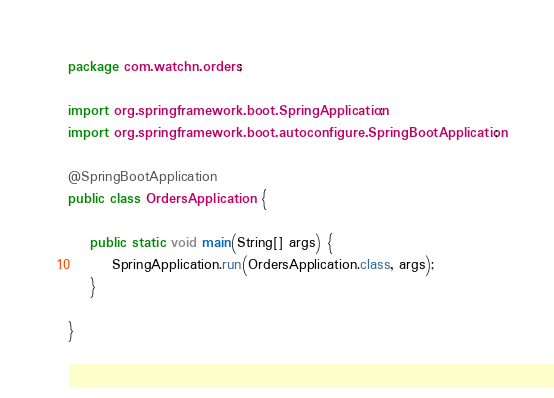<code> <loc_0><loc_0><loc_500><loc_500><_Java_>package com.watchn.orders;

import org.springframework.boot.SpringApplication;
import org.springframework.boot.autoconfigure.SpringBootApplication;

@SpringBootApplication
public class OrdersApplication {

	public static void main(String[] args) {
		SpringApplication.run(OrdersApplication.class, args);
	}

}
</code> 